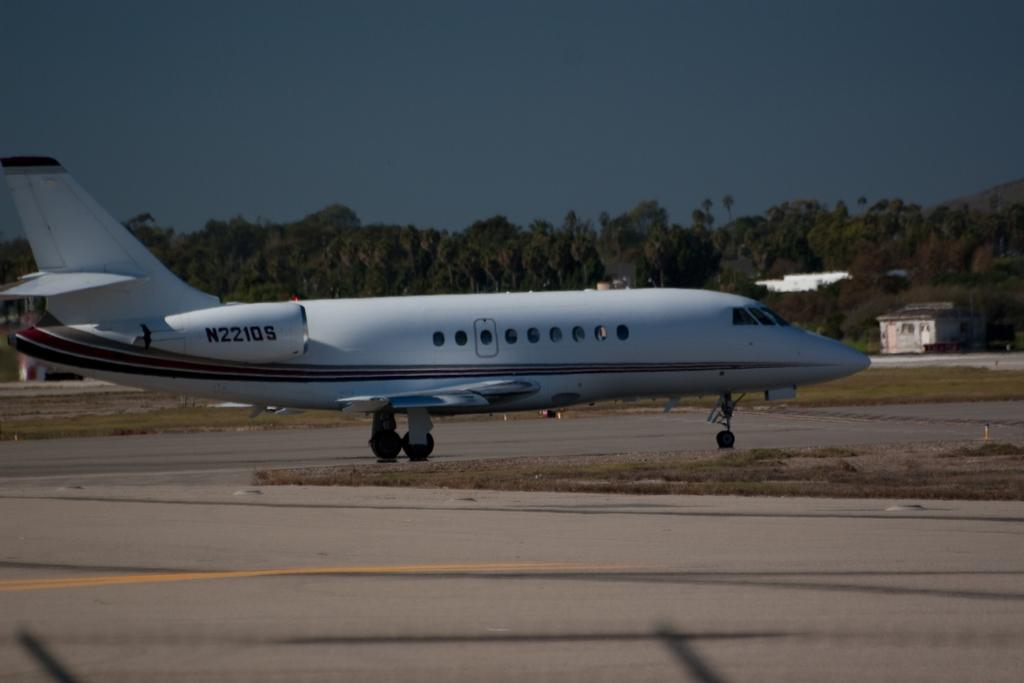What is the color of the airplane in the image? The airplane in the image is white. Where is the airplane located in the image? The airplane is on a runway. What can be seen in the background of the image? There are trees visible in the background of the image. What type of balloon can be seen floating in the wilderness in the image? There is no balloon or wilderness present in the image; it features a white airplane on a runway with trees in the background. What role does zinc play in the functioning of the airplane in the image? There is no mention of zinc or its role in the functioning of the airplane in the image. 